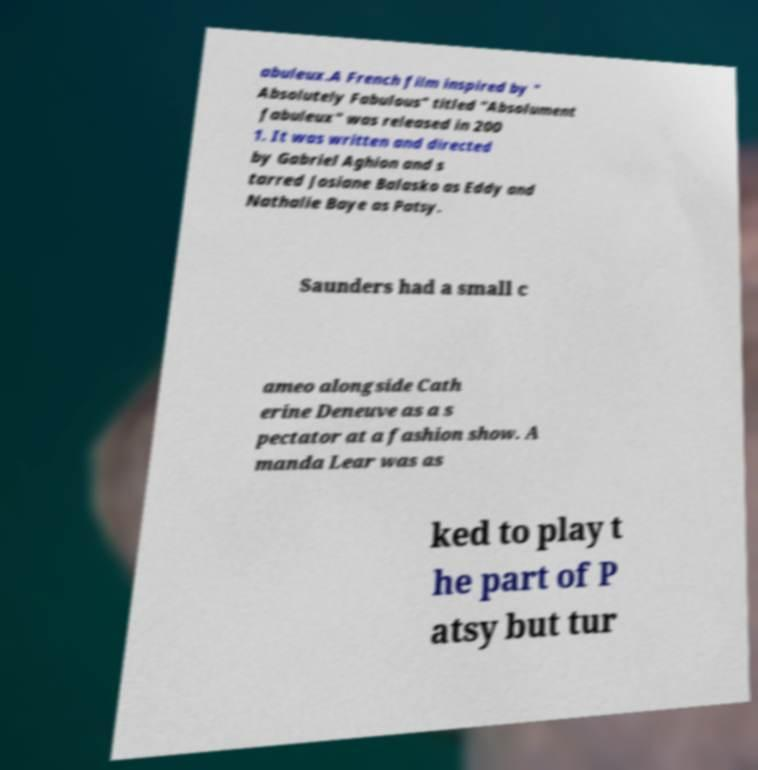Can you accurately transcribe the text from the provided image for me? abuleux.A French film inspired by " Absolutely Fabulous" titled "Absolument fabuleux" was released in 200 1. It was written and directed by Gabriel Aghion and s tarred Josiane Balasko as Eddy and Nathalie Baye as Patsy. Saunders had a small c ameo alongside Cath erine Deneuve as a s pectator at a fashion show. A manda Lear was as ked to play t he part of P atsy but tur 